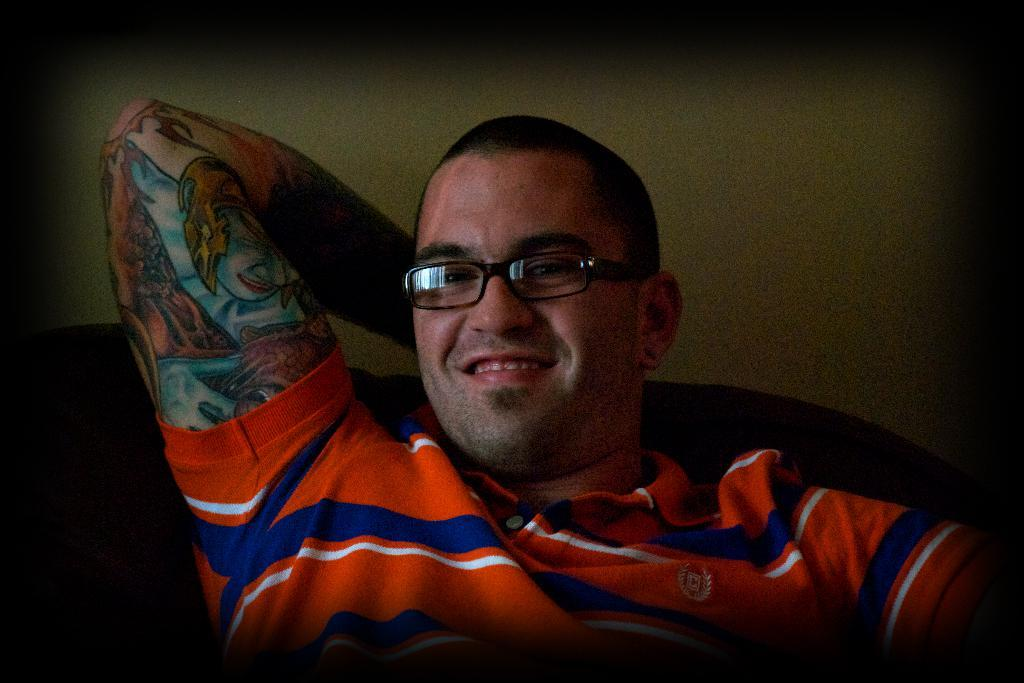Who is present in the image? There is a person in the image. What is the person doing in the image? The person is smiling in the image. What is behind the person in the image? There is a wall behind the person in the image. What can be seen on the person's hand in the image? The person has a tattoo on their hand in the image. What type of toys can be seen on the rail in the image? There is no rail or toys present in the image. 